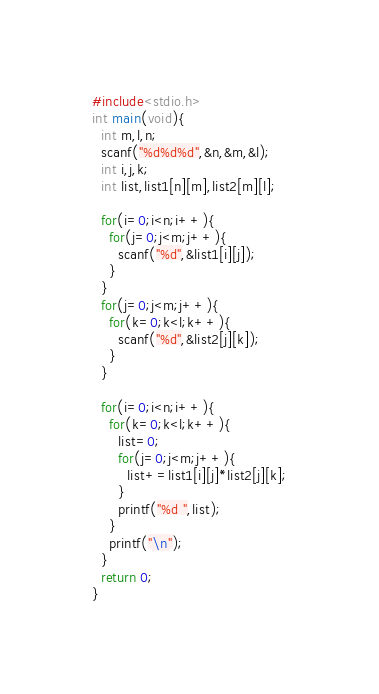<code> <loc_0><loc_0><loc_500><loc_500><_C_>#include<stdio.h>
int main(void){
  int m,l,n;
  scanf("%d%d%d",&n,&m,&l);
  int i,j,k;
  int list,list1[n][m],list2[m][l];

  for(i=0;i<n;i++){
    for(j=0;j<m;j++){
      scanf("%d",&list1[i][j]);
    }
  }
  for(j=0;j<m;j++){
    for(k=0;k<l;k++){
      scanf("%d",&list2[j][k]);
    }
  }

  for(i=0;i<n;i++){
    for(k=0;k<l;k++){
      list=0;
      for(j=0;j<m;j++){
        list+=list1[i][j]*list2[j][k];
      }
      printf("%d ",list);
    }
    printf("\n");
  }
  return 0;
}</code> 